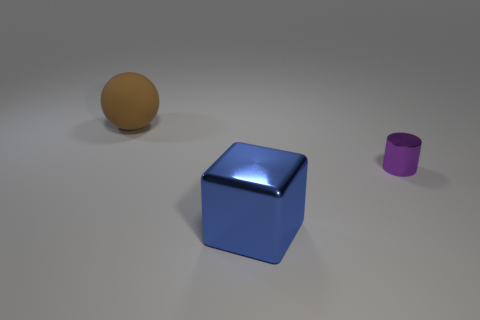Are there any other things that are the same size as the metal cylinder?
Provide a short and direct response. No. What number of things are big brown balls or big objects?
Your answer should be compact. 2. Is the size of the brown object the same as the shiny object that is left of the purple object?
Provide a succinct answer. Yes. How big is the metallic object to the left of the shiny object that is behind the shiny object that is in front of the small purple metallic thing?
Ensure brevity in your answer.  Large. Is there a large brown rubber sphere?
Your answer should be compact. Yes. What number of things are shiny things behind the blue shiny cube or metallic objects that are behind the metallic block?
Offer a terse response. 1. How many objects are right of the object that is behind the small purple cylinder?
Keep it short and to the point. 2. There is a small cylinder that is the same material as the block; what is its color?
Offer a terse response. Purple. Are there any brown spheres that have the same size as the blue metallic object?
Your answer should be very brief. Yes. What is the shape of the blue thing that is the same size as the matte ball?
Provide a succinct answer. Cube. 